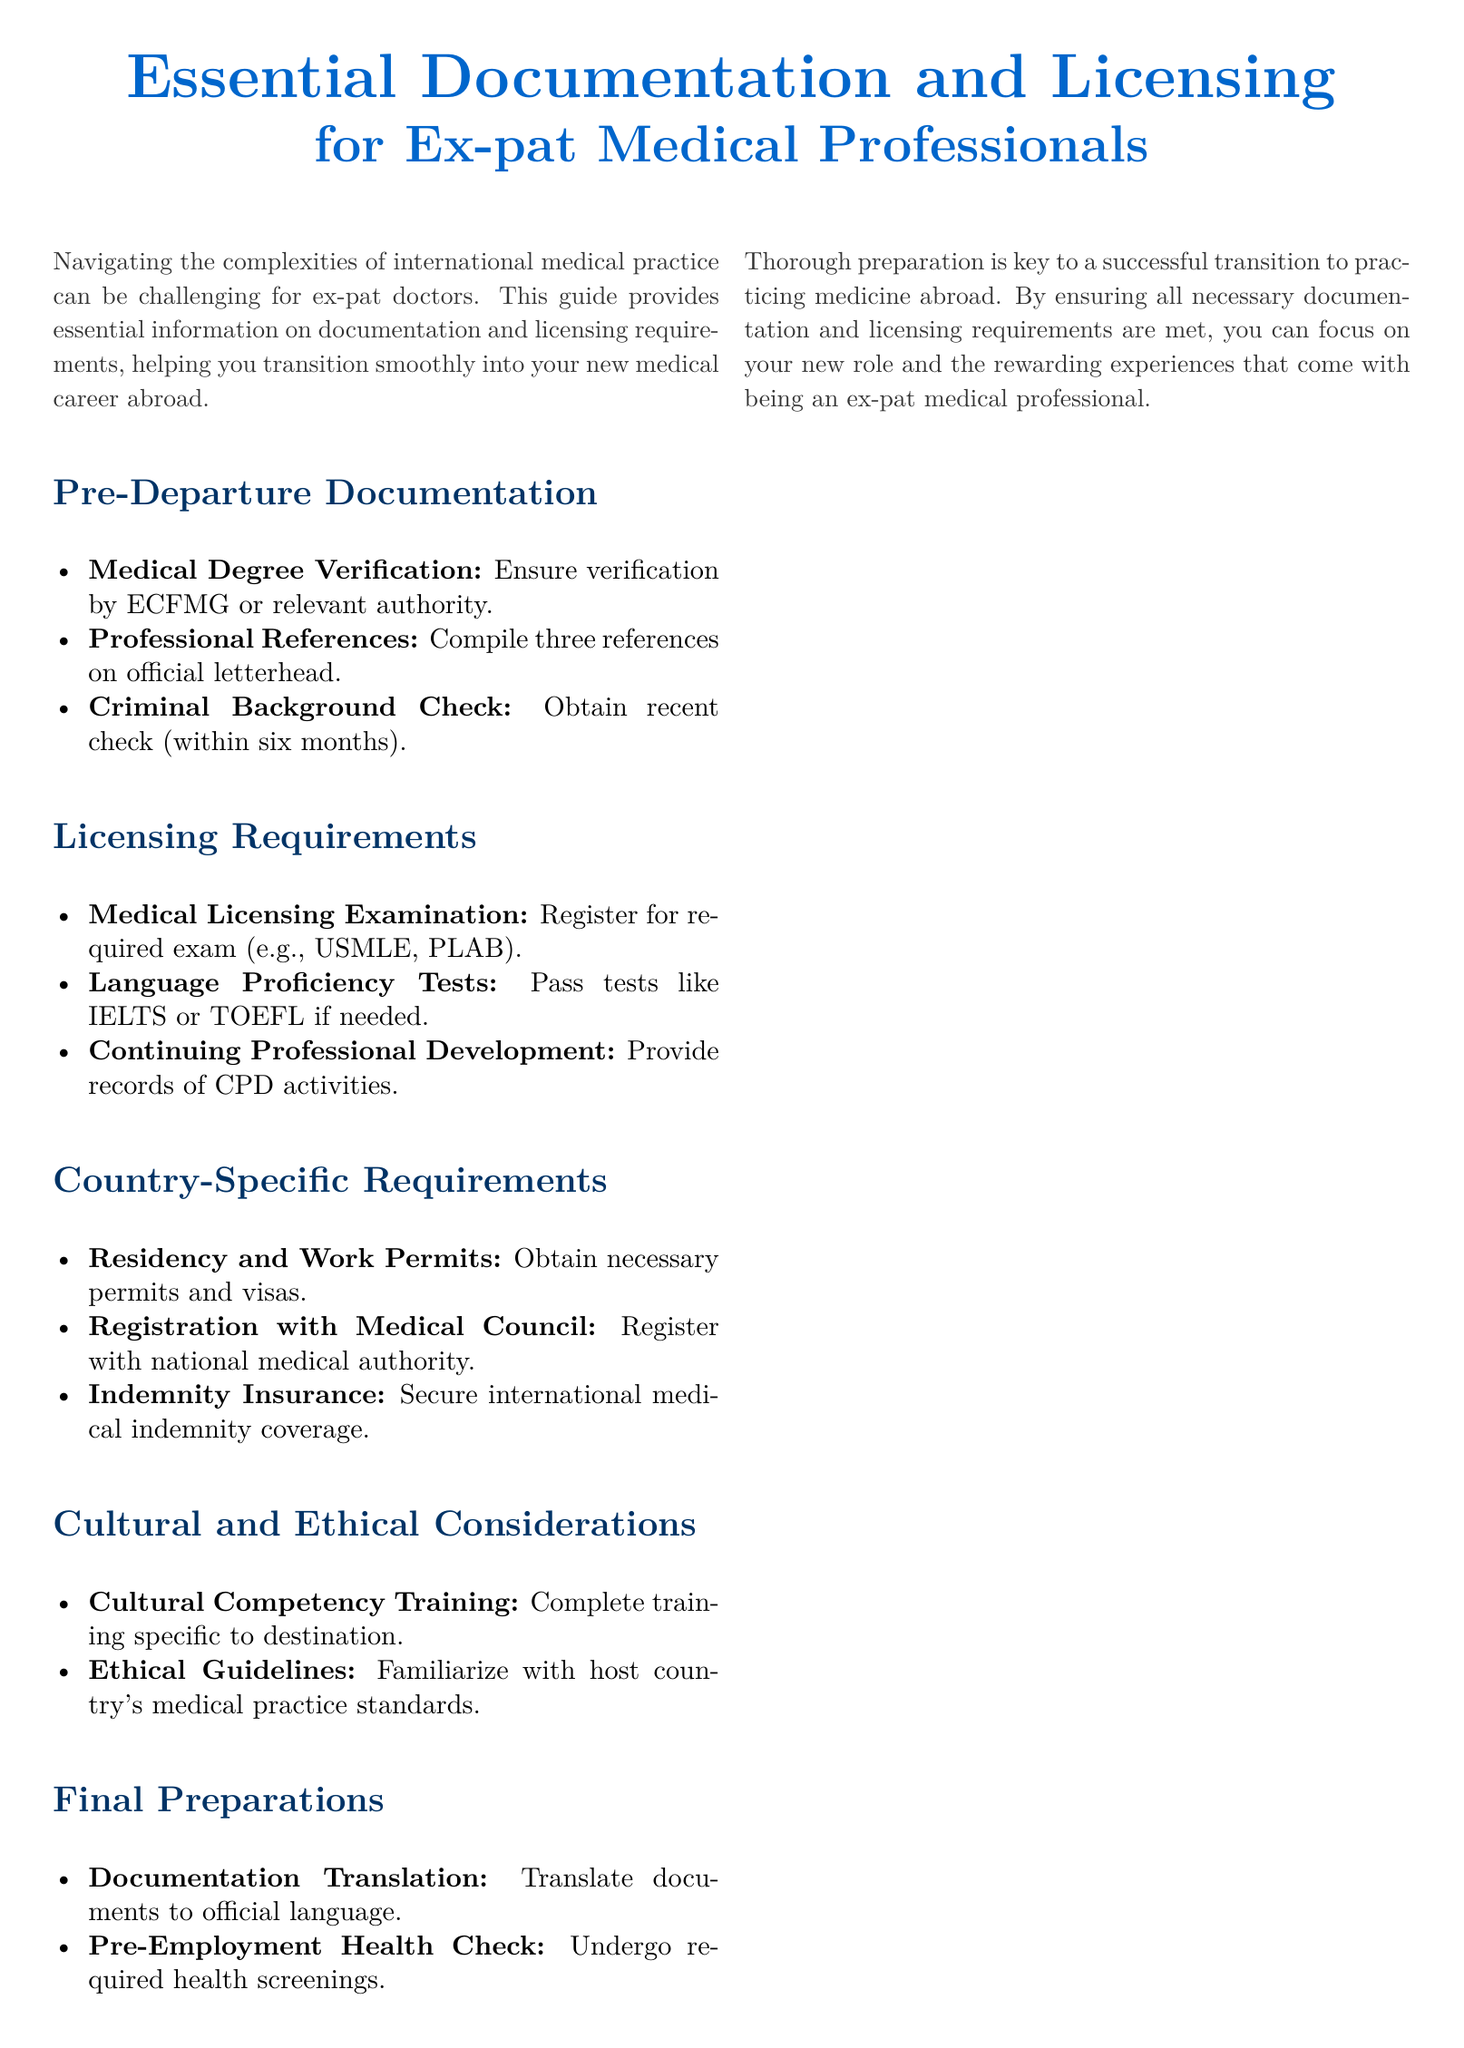What is required for Medical Degree Verification? Medical Degree Verification requires verification by ECFMG or relevant authority.
Answer: ECFMG or relevant authority How many professional references are needed? The document specifies compiling three references on official letterhead.
Answer: Three references What must be completed before departure? The section on Final Preparations mentions documentation translation as a necessary step.
Answer: Documentation Translation What exam might be required for licensing? The Licensing Requirements section mentions the Medical Licensing Examination, which includes exams like USMLE or PLAB.
Answer: USMLE or PLAB What type of insurance should ex-pat doctors obtain? The Country-Specific Requirements section advises securing international medical indemnity coverage.
Answer: International medical indemnity coverage What training is suggested for cultural competency? The document recommends completing cultural competency training specific to the destination.
Answer: Cultural competency training How often should Continuing Professional Development be documented? The document states that records of CPD activities should be provided during the licensing process.
Answer: As required What is an essential part of the pre-employment process? Undergoing a required health screening is mentioned in the Final Preparations section.
Answer: Pre-Employment Health Check Which proficiency tests might be necessary? The Licensing Requirements section mentions language proficiency tests like IELTS or TOEFL.
Answer: IELTS or TOEFL 